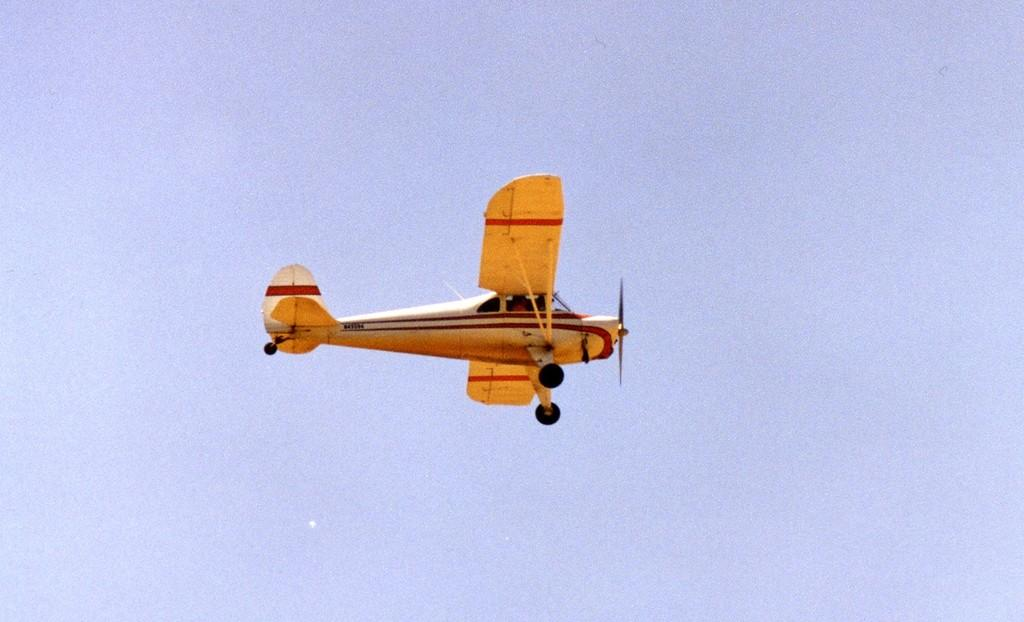What is the main subject of the picture? The main subject of the picture is an airplane. What is the airplane doing in the image? The airplane is flying in the air. What color is the airplane? The airplane is yellow in color. What can be seen in the background of the image? The sky is visible in the background of the image. Can you see any rub or wire attached to the airplane in the image? There is no mention of rub or wire in the image, and therefore we cannot see any in the image. Are there any feathers visible on the airplane in the image? There are no feathers visible on the airplane in the image, as airplanes are not typically associated with feathers. 